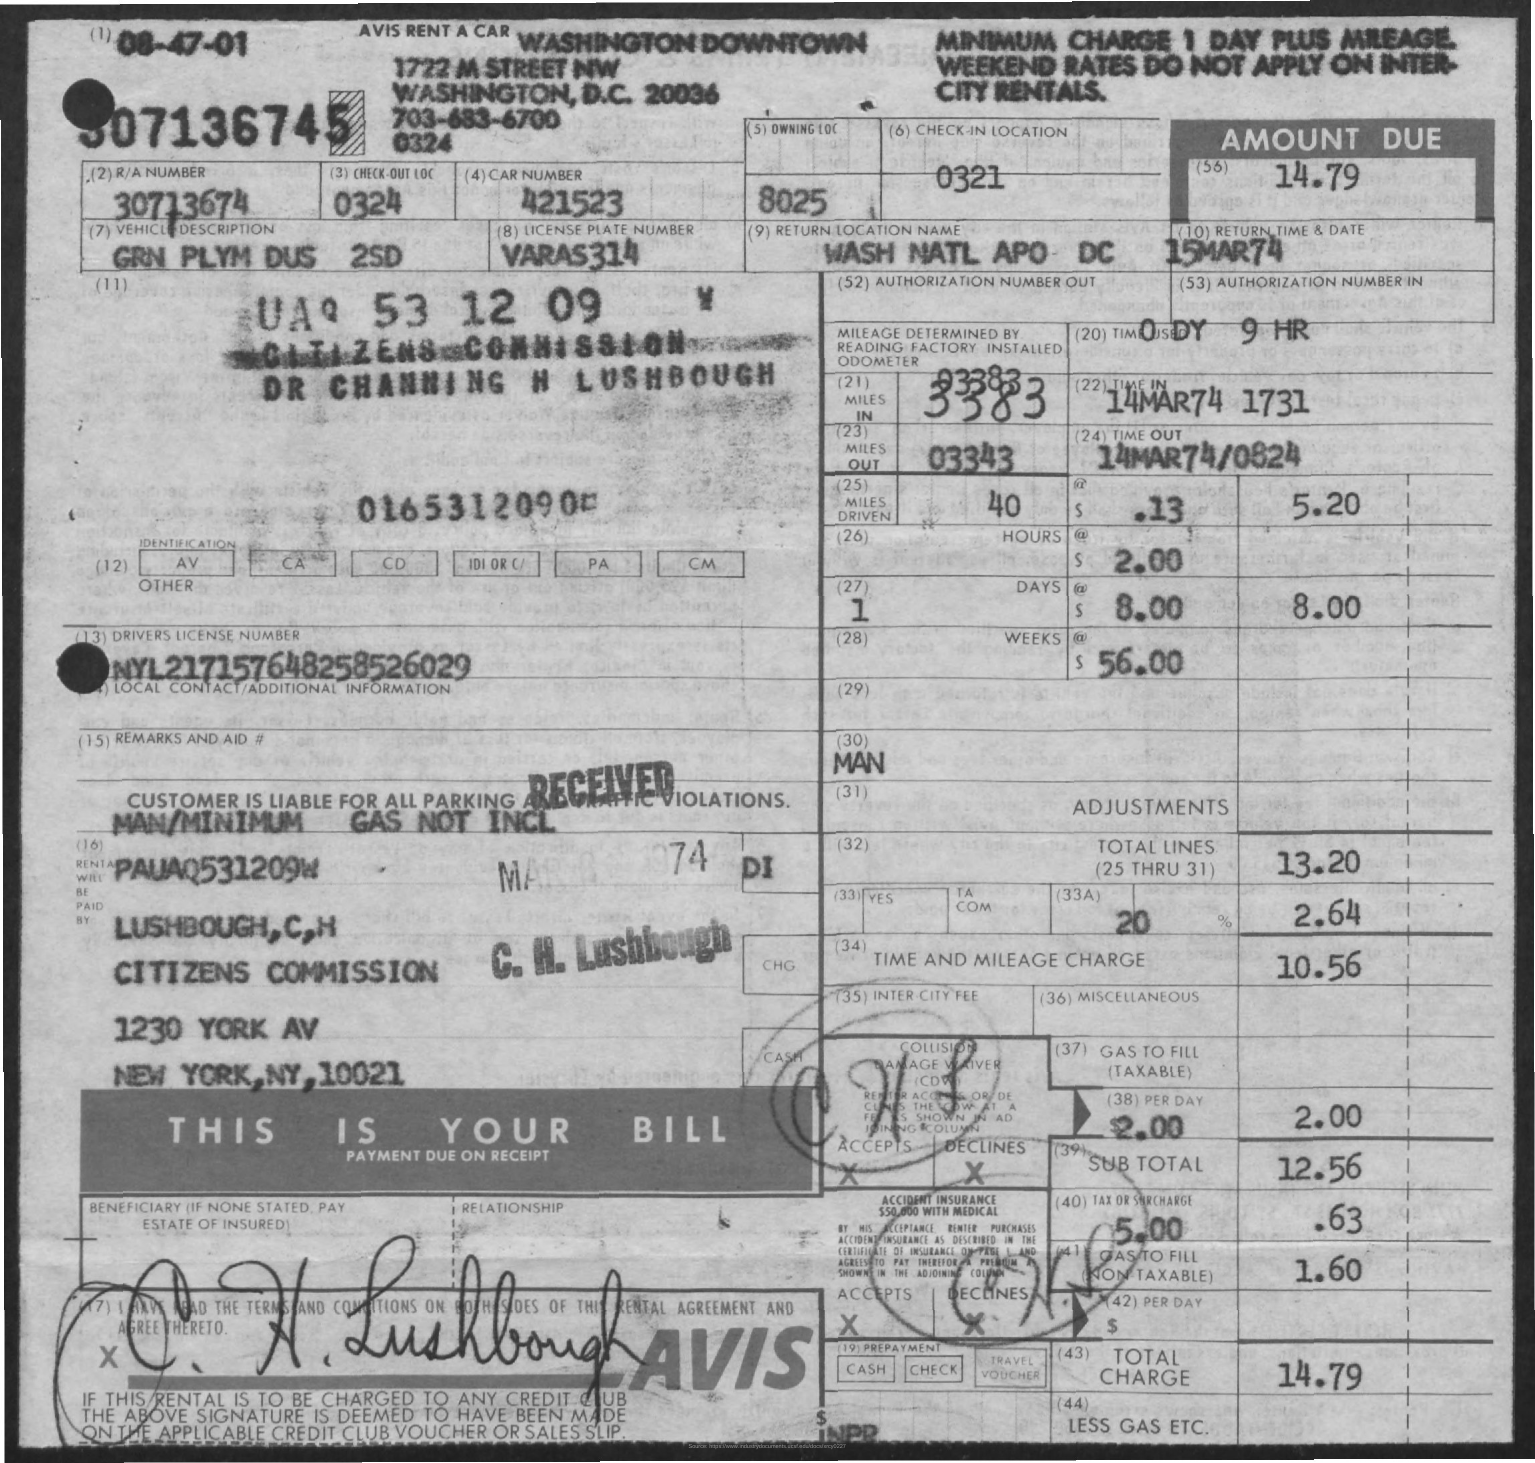List a handful of essential elements in this visual. What is the return date? March 15, 1974, is the specified date. The return location name is "WASH NATL APO DC". The R/A number is 30713674... The car number is 421523... What is the Check-out LOC? It is a sequence of numbers starting from 0324... 